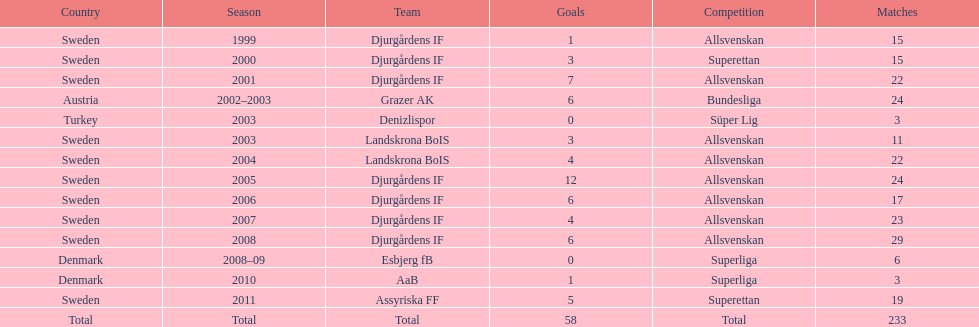What is the total number of matches? 233. 